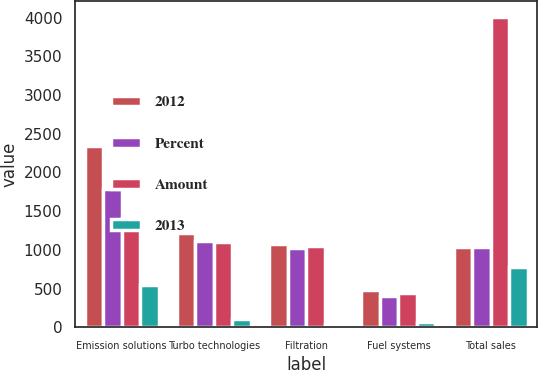<chart> <loc_0><loc_0><loc_500><loc_500><stacked_bar_chart><ecel><fcel>Emission solutions<fcel>Turbo technologies<fcel>Filtration<fcel>Fuel systems<fcel>Total sales<nl><fcel>2012<fcel>2343<fcel>1222<fcel>1075<fcel>478<fcel>1038<nl><fcel>Percent<fcel>1791<fcel>1115<fcel>1028<fcel>408<fcel>1038<nl><fcel>Amount<fcel>1415<fcel>1106<fcel>1048<fcel>443<fcel>4012<nl><fcel>2013<fcel>552<fcel>107<fcel>47<fcel>70<fcel>776<nl></chart> 